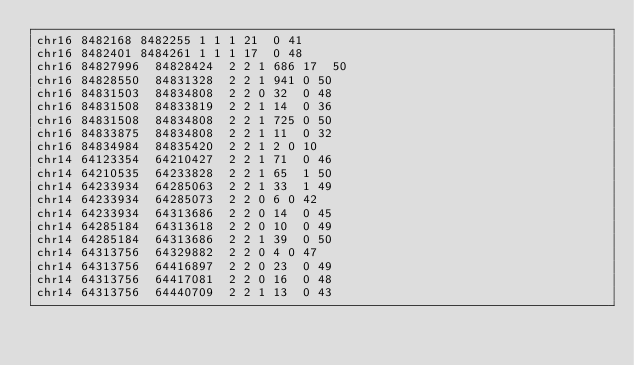Convert code to text. <code><loc_0><loc_0><loc_500><loc_500><_SQL_>chr16	8482168	8482255	1	1	1	21	0	41
chr16	8482401	8484261	1	1	1	17	0	48
chr16	84827996	84828424	2	2	1	686	17	50
chr16	84828550	84831328	2	2	1	941	0	50
chr16	84831503	84834808	2	2	0	32	0	48
chr16	84831508	84833819	2	2	1	14	0	36
chr16	84831508	84834808	2	2	1	725	0	50
chr16	84833875	84834808	2	2	1	11	0	32
chr16	84834984	84835420	2	2	1	2	0	10
chr14	64123354	64210427	2	2	1	71	0	46
chr14	64210535	64233828	2	2	1	65	1	50
chr14	64233934	64285063	2	2	1	33	1	49
chr14	64233934	64285073	2	2	0	6	0	42
chr14	64233934	64313686	2	2	0	14	0	45
chr14	64285184	64313618	2	2	0	10	0	49
chr14	64285184	64313686	2	2	1	39	0	50
chr14	64313756	64329882	2	2	0	4	0	47
chr14	64313756	64416897	2	2	0	23	0	49
chr14	64313756	64417081	2	2	0	16	0	48
chr14	64313756	64440709	2	2	1	13	0	43</code> 